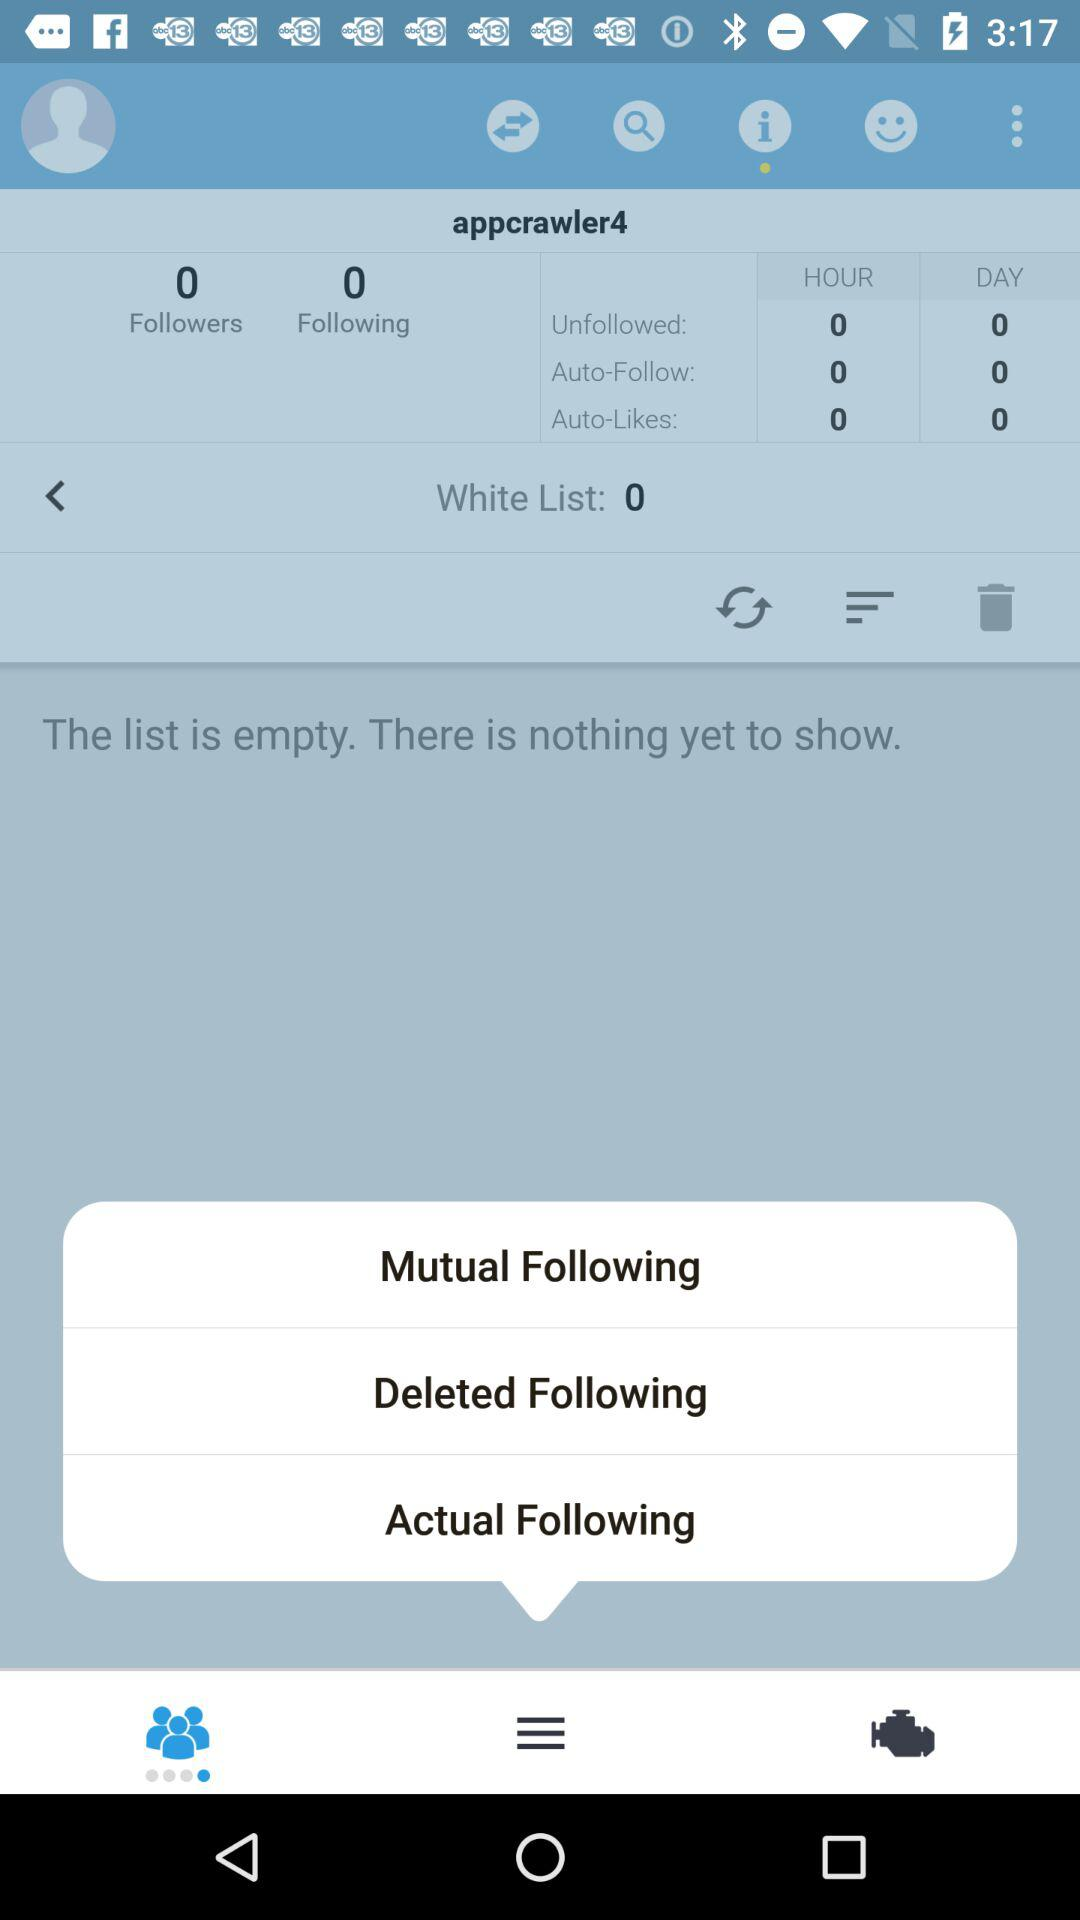How many auto-likes are there per day? There are 0 auto-likes per day. 